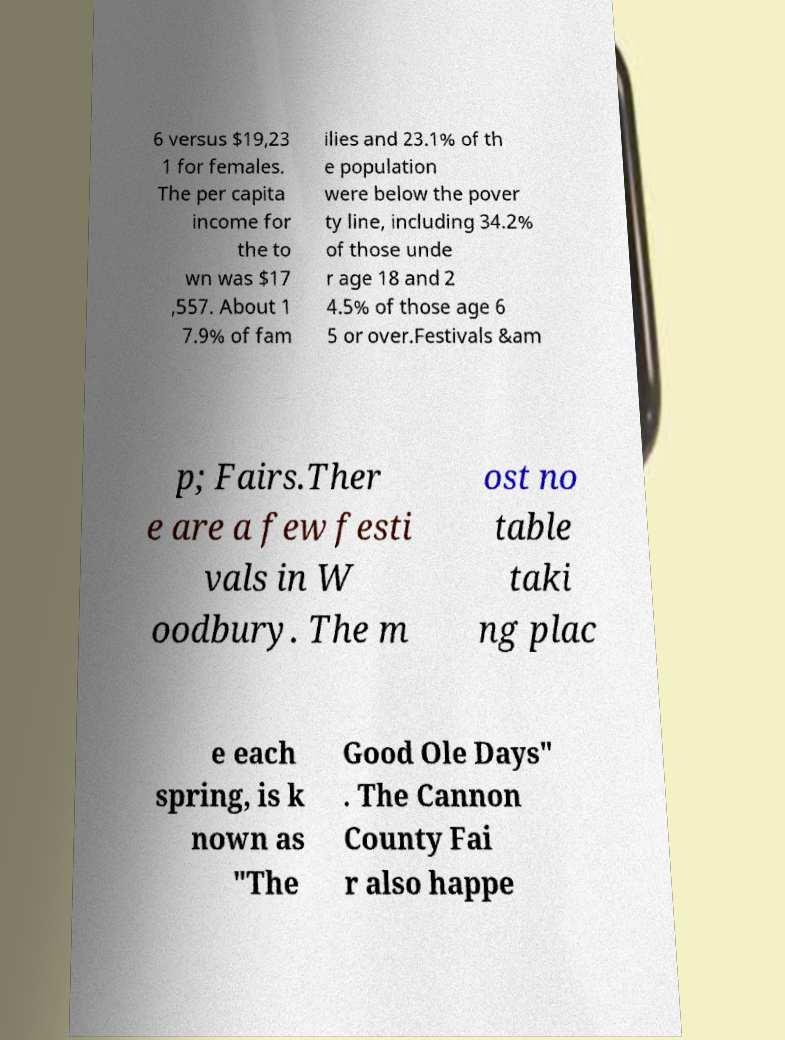I need the written content from this picture converted into text. Can you do that? 6 versus $19,23 1 for females. The per capita income for the to wn was $17 ,557. About 1 7.9% of fam ilies and 23.1% of th e population were below the pover ty line, including 34.2% of those unde r age 18 and 2 4.5% of those age 6 5 or over.Festivals &am p; Fairs.Ther e are a few festi vals in W oodbury. The m ost no table taki ng plac e each spring, is k nown as "The Good Ole Days" . The Cannon County Fai r also happe 